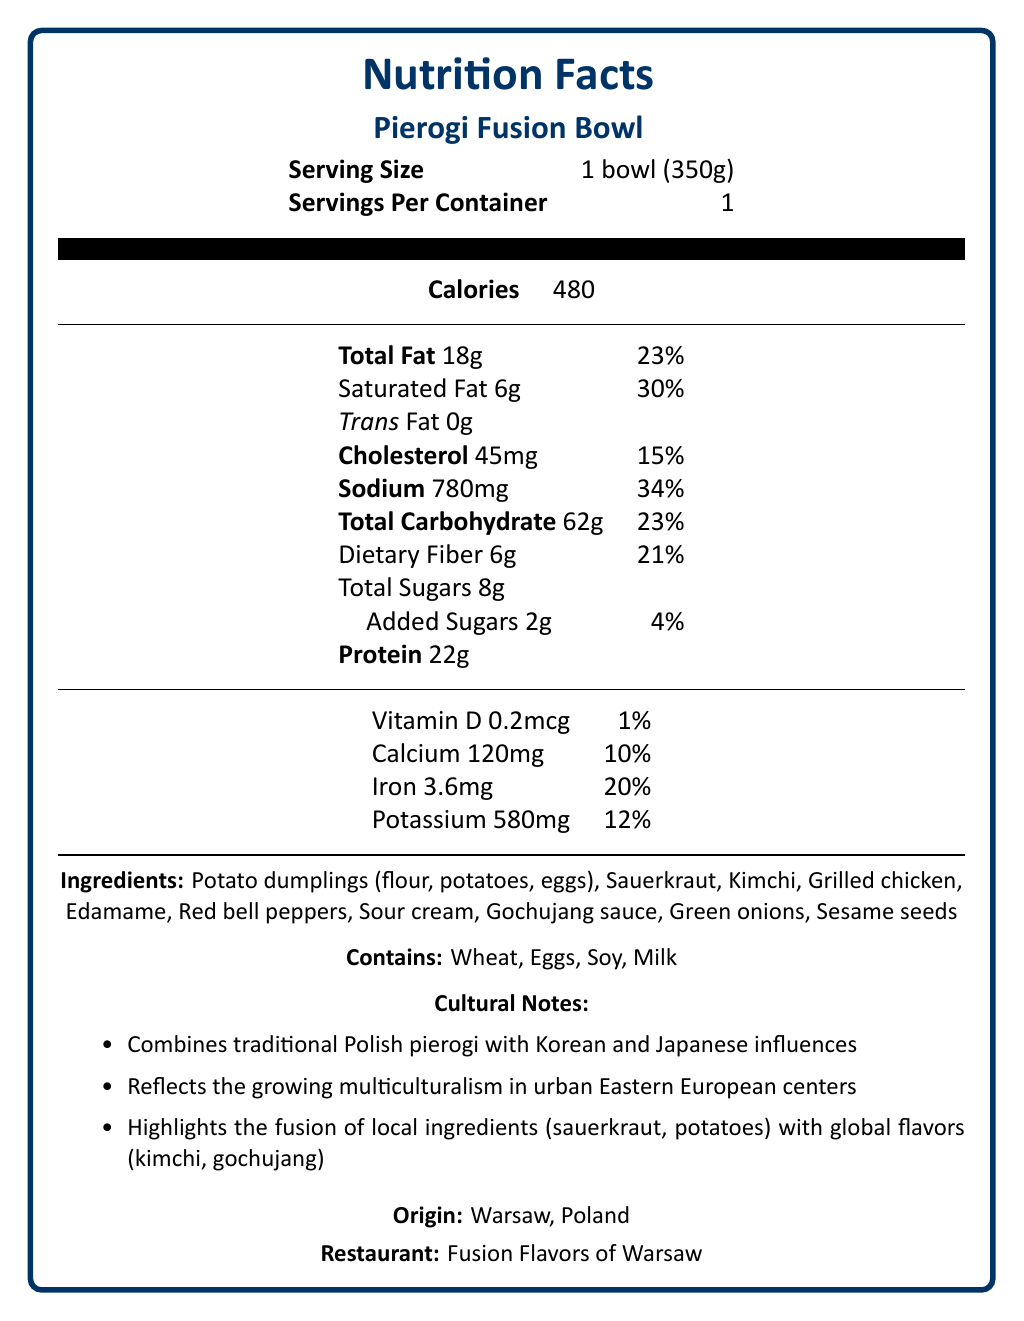what is the product name? The document states "Pierogi Fusion Bowl" as the product name at the beginning.
Answer: Pierogi Fusion Bowl what is the serving size of the Pierogi Fusion Bowl? The serving size is mentioned as "1 bowl (350g)" under the "Serving Size" section.
Answer: 1 bowl (350g) what is the total fat content in one serving of the Pierogi Fusion Bowl? The "Total Fat" content is listed as 18g in one serving.
Answer: 18g what ingredients are included in the Pierogi Fusion Bowl? The ingredients list includes these items under the "Ingredients" section.
Answer: Potato dumplings, Sauerkraut, Kimchi, Grilled chicken, Edamame, Red bell peppers, Sour cream, Gochujang sauce, Green onions, Sesame seeds what percentage of daily value for sodium does one serving of the Pierogi Fusion Bowl provide? The document lists the sodium content as 780mg, which is 34% of the daily value.
Answer: 34% which allergens are present in the Pierogi Fusion Bowl? A. Wheat, Eggs, Soy B. Wheat, Eggs, Soy, Milk C. Wheat, Soy, Milk D. Eggs, Milk, Soy The allergen information includes Wheat, Eggs, Soy, and Milk.
Answer: B. Wheat, Eggs, Soy, Milk what is the main cultural influence combined with traditional Polish pierogi in this dish? A. Korean B. Japanese C. Both Korean and Japanese D. Chinese The cultural notes specify that the dish combines traditional Polish pierogi with Korean and Japanese influences.
Answer: C. Both Korean and Japanese does the Pierogi Fusion Bowl contain any trans fat? The document lists trans fat as 0g, indicating that there is no trans fat present.
Answer: No what is the preparation method for the Pierogi Fusion Bowl? The preparation method is mentioned at the end of the document in the "preparation method" section.
Answer: Boiled pierogi served in a bowl with sautéed vegetables, grilled chicken, and fusion sauces where is the Pierogi Fusion Bowl originated from and which restaurant offers it? The origin is listed as "Warsaw, Poland" and the restaurant is "Fusion Flavors of Warsaw".
Answer: Warsaw, Poland and Fusion Flavors of Warsaw what are some of the key features highlighted in the cultural notes? The cultural notes detail these key features of the Pierogi Fusion Bowl.
Answer: Combines traditional Polish pierogi with Korean and Japanese influences, reflects growing multiculturalism, highlights fusion of local ingredients with global flavors summarize the main nutritional components and cultural significance of the Pierogi Fusion Bowl This summary provides an overview of the nutritional content and cultural significance as described in various sections of the document.
Answer: The Pierogi Fusion Bowl is a 350g serving that contains 480 calories, 18g total fat, 6g saturated fat, 45mg cholesterol, 780mg sodium, 62g total carbohydrates, 6g dietary fiber, 8g total sugars (2g added sugars), and 22g protein. It features ingredients such as potato dumplings, sauerkraut, kimchi, grilled chicken, edamame, and gochujang sauce. The dish highlights a blend of traditional Polish cuisine with Korean and Japanese culinary influences, reflecting the multiculturalism in urban Eastern European centers. what is the percentage of daily value for protein provided by the Pierogi Fusion Bowl? The document specifies the amount of protein (22g) but does not provide the percentage of the daily value for protein.
Answer: Cannot be determined what is the amount of Vitamin D in one serving? The document lists the Vitamin D content as 0.2mcg.
Answer: 0.2mcg how does the ingredient list reflect the cultural fusion highlighted in the cultural notes? The ingredient list illustrates the fusion by combining traditional Polish items with Korean and Japanese culinary elements.
Answer: The inclusion of sauerkraut and potato dumplings represents traditional Polish ingredients, while kimchi and gochujang sauce reflect Korean influences, and edamame is often associated with Japanese cuisine. 